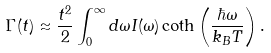<formula> <loc_0><loc_0><loc_500><loc_500>\Gamma ( t ) \approx \frac { t ^ { 2 } } { 2 } \int _ { 0 } ^ { \infty } d \omega I ( \omega ) \coth \left ( \frac { \hbar { \omega } } { k _ { B } T } \right ) .</formula> 